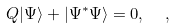Convert formula to latex. <formula><loc_0><loc_0><loc_500><loc_500>Q | \Psi \rangle + | \Psi ^ { * } \Psi \rangle = 0 , \ \ ,</formula> 